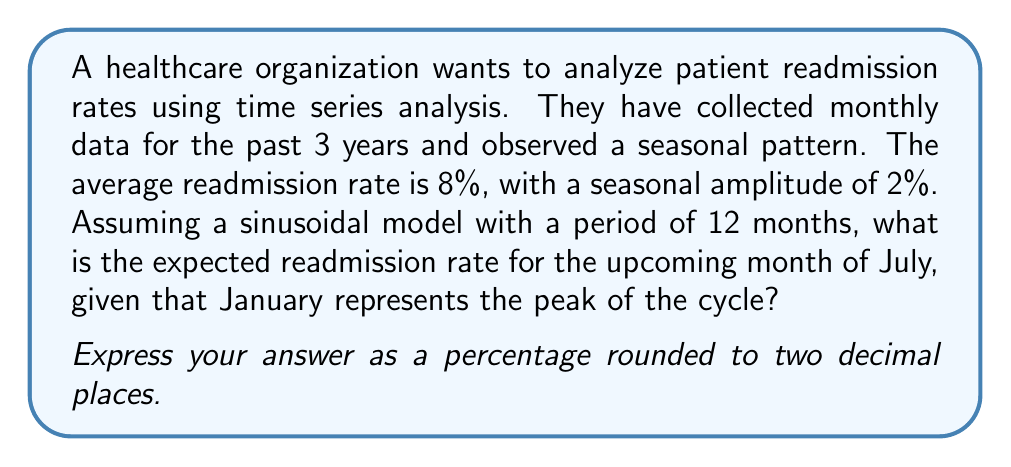Teach me how to tackle this problem. To solve this problem, we need to use a sinusoidal model for time series analysis. The general form of a sinusoidal function is:

$$y(t) = A + B \sin\left(\frac{2\pi}{T}(t-C)\right)$$

Where:
$A$ is the average value (baseline)
$B$ is the amplitude
$T$ is the period
$t$ is the time
$C$ is the phase shift

Given:
- Average readmission rate (A) = 8%
- Seasonal amplitude (B) = 2%
- Period (T) = 12 months
- January is the peak of the cycle (C = 0)

Step 1: Determine the time t for July.
Since January is the peak (month 1), July is the 7th month in the cycle.

Step 2: Plug the values into the sinusoidal function.

$$y(7) = 8 + 2 \sin\left(\frac{2\pi}{12}(7-0)\right)$$

Step 3: Simplify the expression inside the sine function.

$$y(7) = 8 + 2 \sin\left(\frac{7\pi}{6}\right)$$

Step 4: Calculate the value of $\sin\left(\frac{7\pi}{6}\right)$.

$$\sin\left(\frac{7\pi}{6}\right) = -\frac{\sqrt{3}}{2} \approx -0.866$$

Step 5: Complete the calculation.

$$y(7) = 8 + 2 \times (-0.866) = 8 - 1.732 = 6.268$$

Step 6: Round to two decimal places and express as a percentage.

6.268% ≈ 6.27%
Answer: 6.27% 